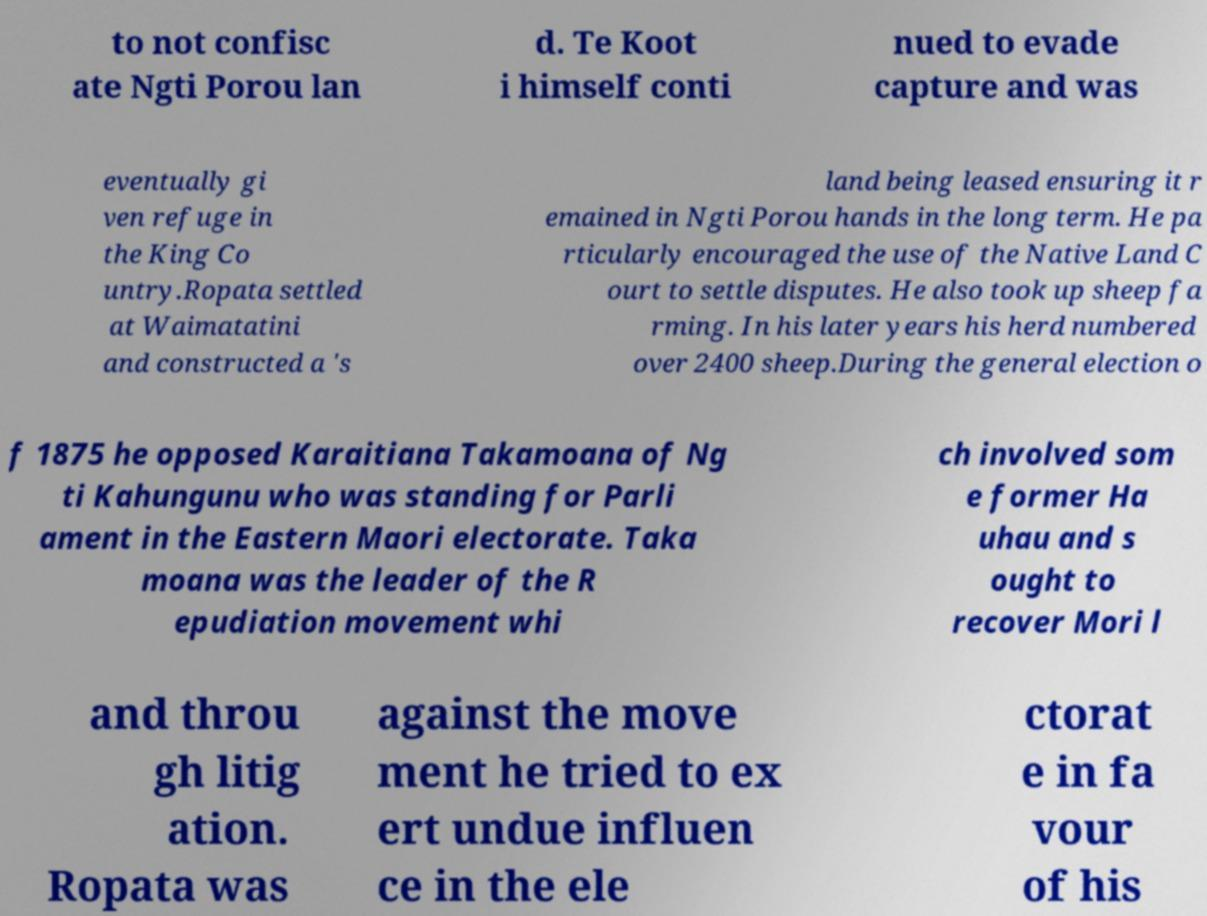Can you read and provide the text displayed in the image?This photo seems to have some interesting text. Can you extract and type it out for me? to not confisc ate Ngti Porou lan d. Te Koot i himself conti nued to evade capture and was eventually gi ven refuge in the King Co untry.Ropata settled at Waimatatini and constructed a 's land being leased ensuring it r emained in Ngti Porou hands in the long term. He pa rticularly encouraged the use of the Native Land C ourt to settle disputes. He also took up sheep fa rming. In his later years his herd numbered over 2400 sheep.During the general election o f 1875 he opposed Karaitiana Takamoana of Ng ti Kahungunu who was standing for Parli ament in the Eastern Maori electorate. Taka moana was the leader of the R epudiation movement whi ch involved som e former Ha uhau and s ought to recover Mori l and throu gh litig ation. Ropata was against the move ment he tried to ex ert undue influen ce in the ele ctorat e in fa vour of his 